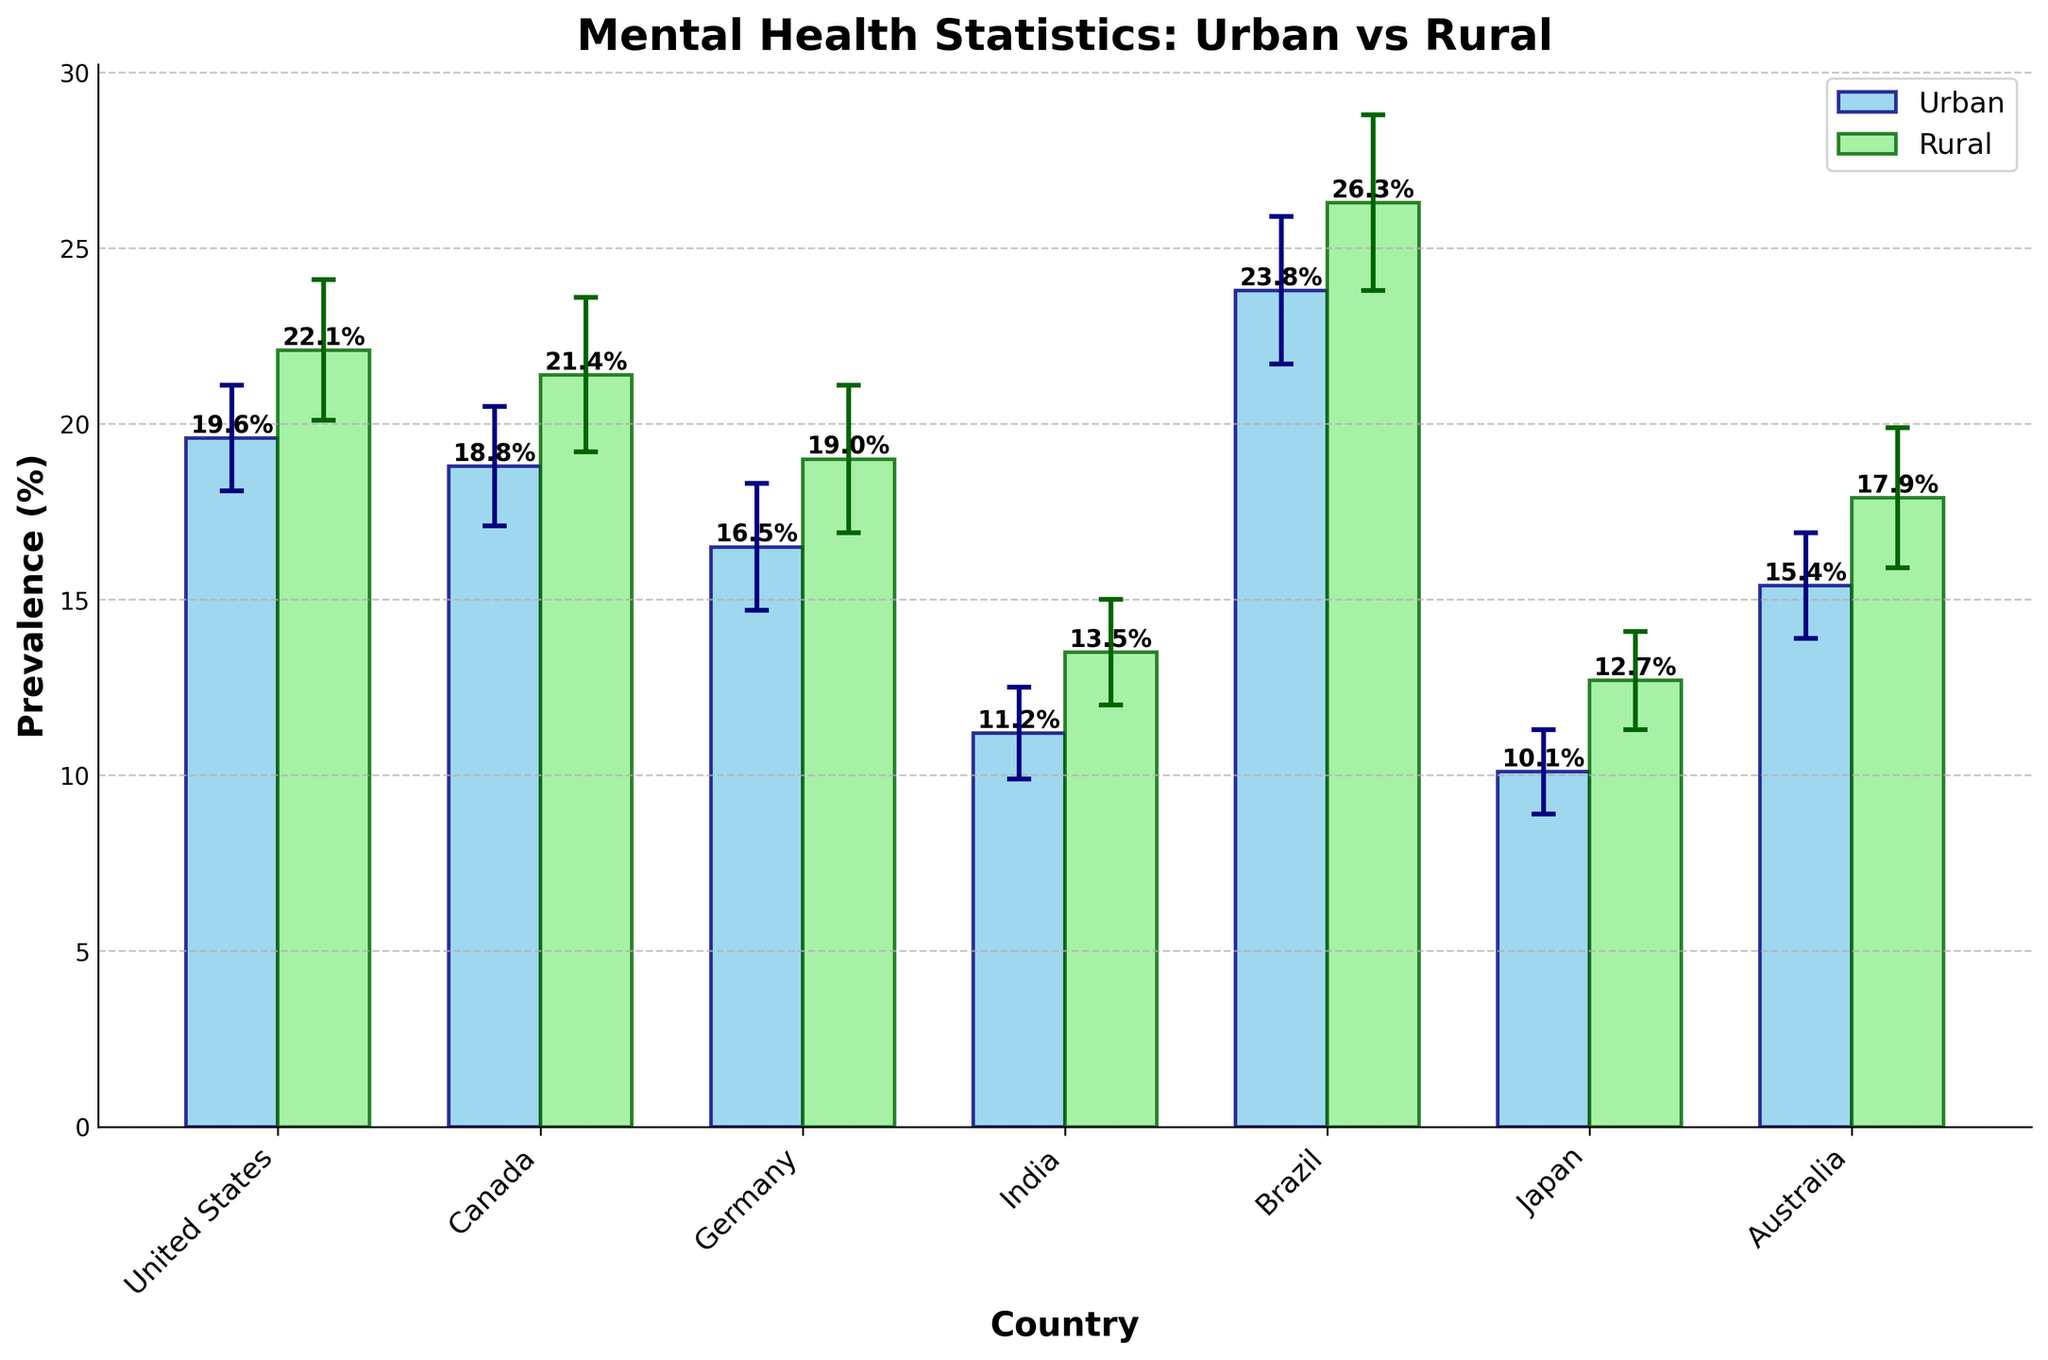What is the title of the plot? The title is located at the top center of the plot and is written in bold font.
Answer: Mental Health Statistics: Urban vs Rural Which country shows the highest prevalence of mental disorders in rural areas? By examining the heights of the rural bars, Brazil has the tallest bar, indicating the highest prevalence.
Answer: Brazil What is the prevalence of depression in urban Canada? Look for the bar corresponding to Canada in urban areas and check its height for the prevalence percentage.
Answer: 18.8% How does the prevalence of anxiety in rural Brazil compare to urban Brazil? Compare the heights of the bars for rural and urban populations in Brazil. The rural bar is taller than the urban bar.
Answer: Rural prevalence is higher What are the error values for the rural populations in Canada and Germany? Check the error bars associated with the rural bars for Canada and Germany. Canada has an error of 2.2%, and Germany has an error of 2.1%.
Answer: 2.2% (Canada), 2.1% (Germany) What is the combined prevalence of anxiety in urban and rural India? Add the prevalence percentages for urban and rural populations in India and sum them up.
Answer: 11.2% + 13.5% = 24.7% What is the average prevalence of anxiety in urban Brazil and rural United States? Sum the prevalence percentages for anxiety in urban Brazil and rural United States and divide by 2.
Answer: (23.8% + 22.1%) / 2 = 22.95% Which country has the smallest error value for urban populations? Compare the error bar lengths of the urban populations to find the smallest. Japan has an error of 1.2%, which is the smallest.
Answer: Japan What is the difference in prevalence of depression between urban and rural populations in Australia? Subtract the urban prevalence percentage in Australia from the rural prevalence percentage.
Answer: 17.9% - 15.4% = 2.5% Is the prevalence of depression higher in urban or rural Japan? Compare the heights of the urban and rural bars for Japan. The rural bar is taller than the urban bar.
Answer: Rural is higher 